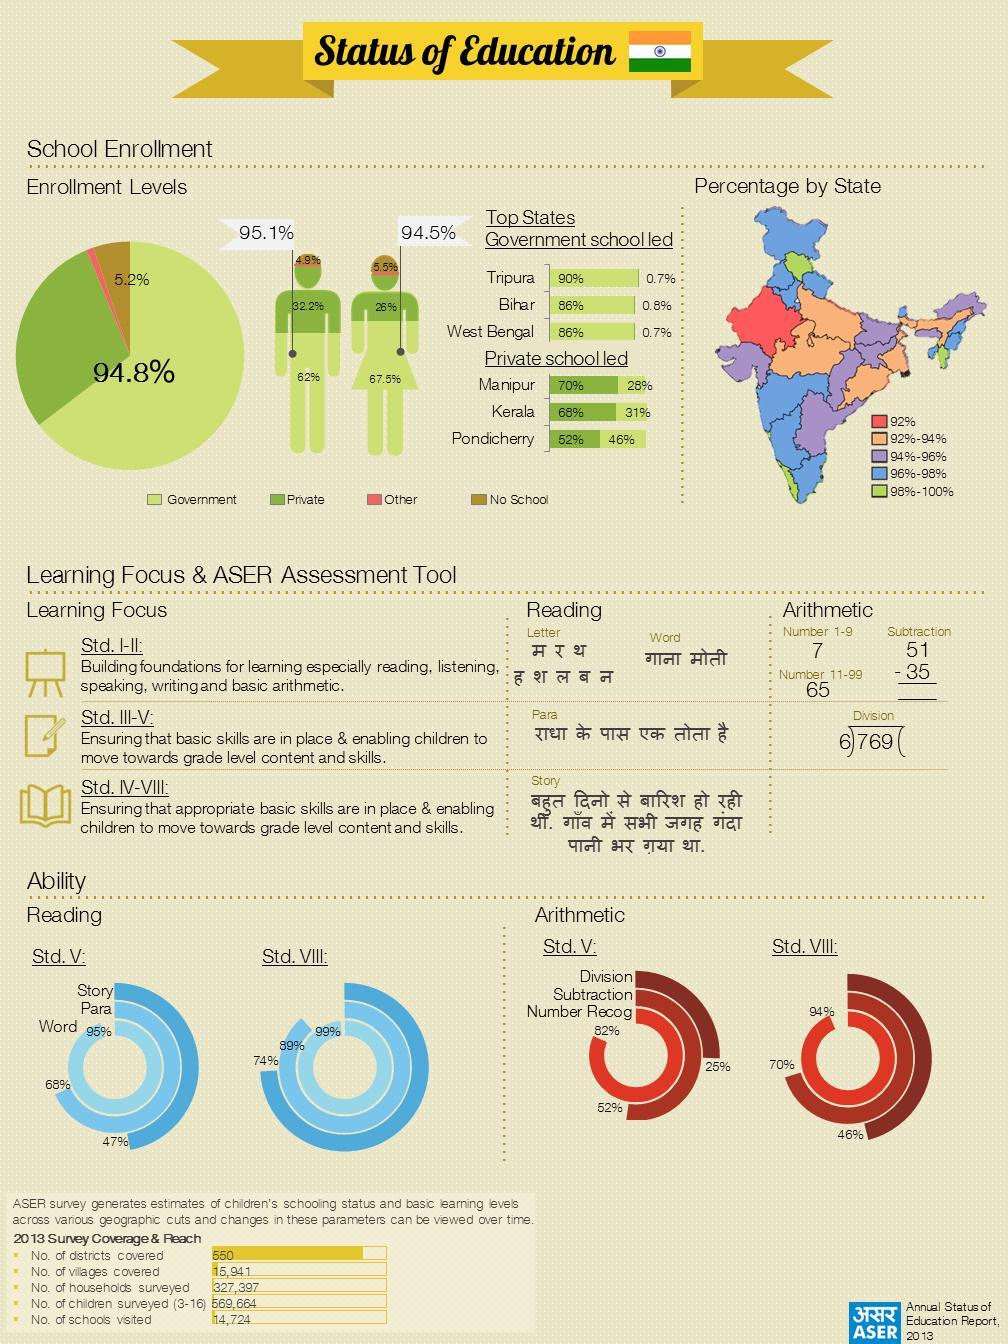Which southern state has a enrollment % between 98%-100%
Answer the question with a short phrase. Kerala Which has the highest share-private, government? government How % is higher the division ability of Std VIII students when compared to Std. V 21 What is the total number of districts and villages, taken together? 16,491 How many states have an enrollment percentage between 98%-100% 3 The arthimetic ability of Std.V and Stid VIII students is highest in what Number Recog How many states have an enrollment percentage between 94%-96% 7 